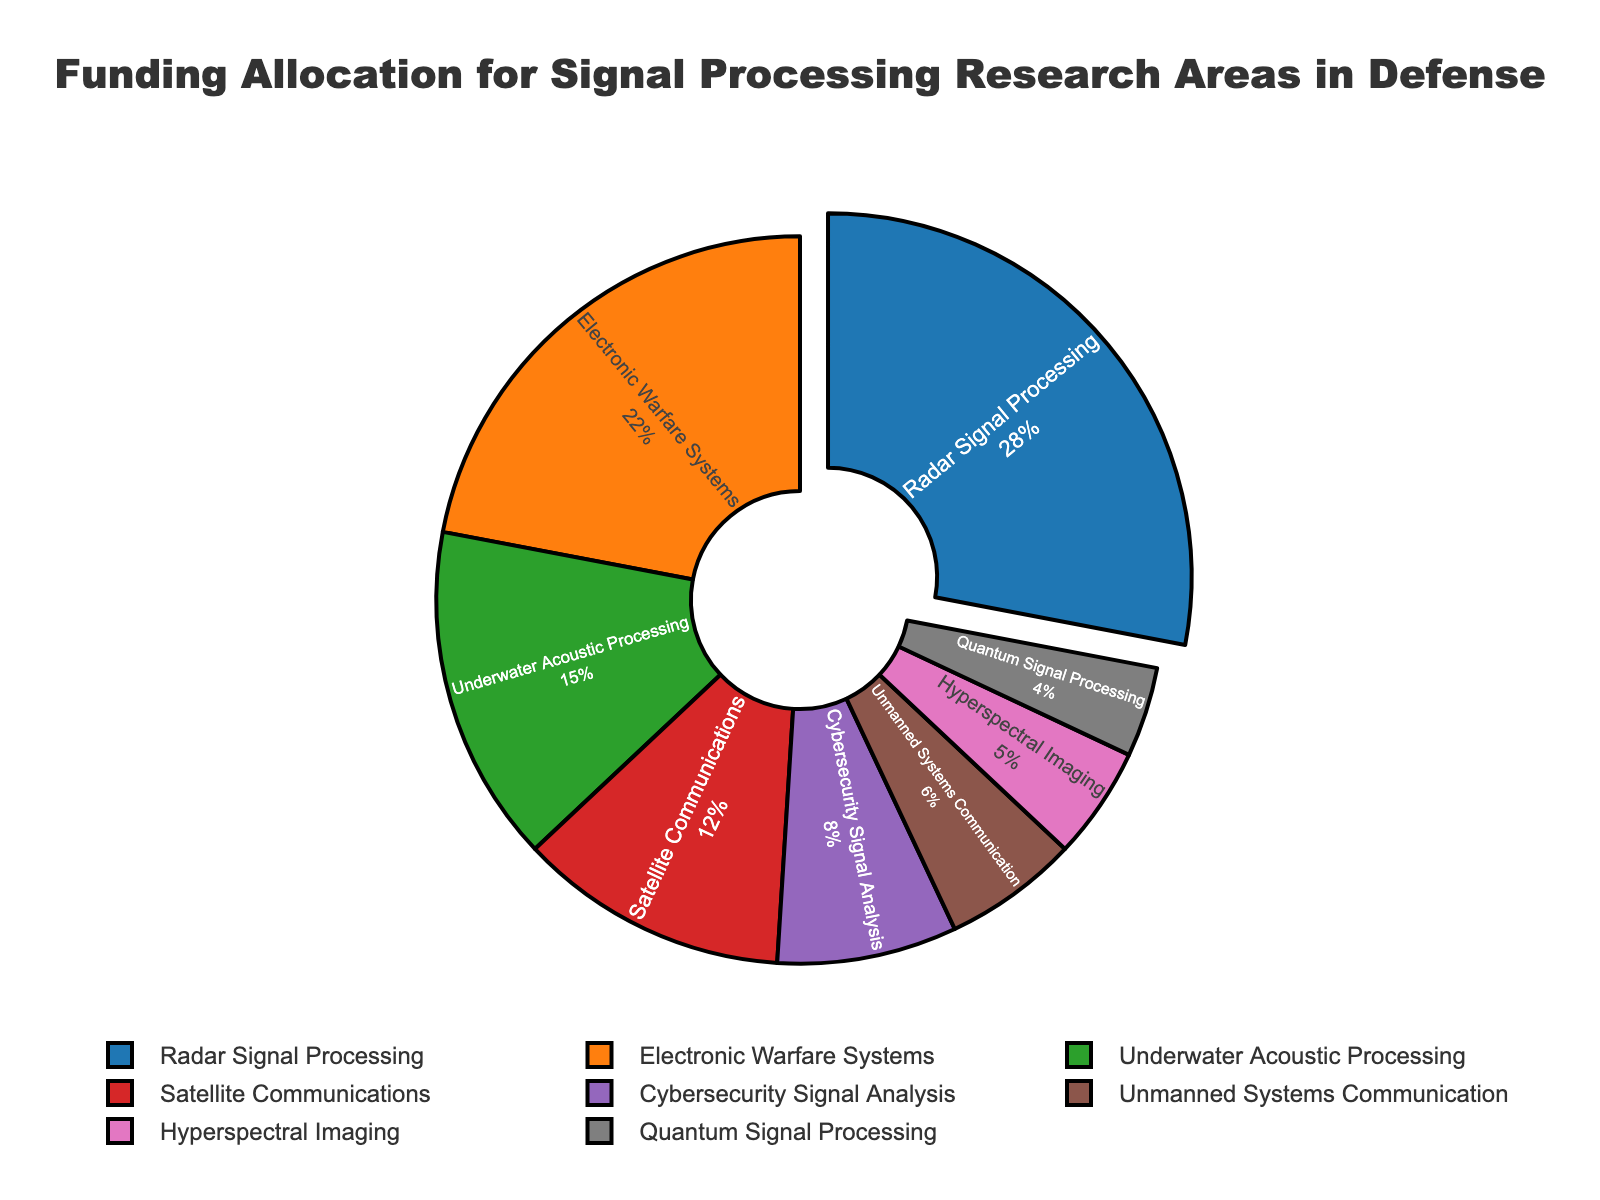Which research area receives the largest portion of funding allocation? The research area with the largest portion of funding allocation is indicated by the section pulled out of the pie chart and also labeled with the highest percentage.
Answer: Radar Signal Processing What is the combined funding allocation percentage for Underwater Acoustic Processing and Satellite Communications? Add the percentages for Underwater Acoustic Processing (15%) and Satellite Communications (12%). 15% + 12% = 27%
Answer: 27% How much more funding allocation is given to Electronic Warfare Systems than to Cybersecurity Signal Analysis? Subtract the funding allocation of Cybersecurity Signal Analysis (8%) from Electronic Warfare Systems (22%). 22% - 8% = 14%
Answer: 14% Which research area has the smallest funding allocation? The smallest section of the pie chart represents Quantum Signal Processing, and it is labeled with 4%.
Answer: Quantum Signal Processing Is the funding allocation for Hyperspectral Imaging greater than for Unmanned Systems Communication? Compare the percentages of Hyperspectral Imaging (5%) and Unmanned Systems Communication (6%). Hyperspectral Imaging has a lower percentage.
Answer: No What is the average funding allocation percentage for Electronic Warfare Systems, Cybersecurity Signal Analysis, and Quantum Signal Processing? Add the percentages of Electronic Warfare Systems (22%), Cybersecurity Signal Analysis (8%), and Quantum Signal Processing (4%), and then divide by 3. (22% + 8% + 4%) / 3 = 34% / 3 ≈ 11.33%
Answer: 11.33% What total percentage of the funding is allotted to the top three research areas? Add the percentages for Radar Signal Processing (28%), Electronic Warfare Systems (22%), and Underwater Acoustic Processing (15%). 28% + 22% + 15% = 65%
Answer: 65% Which color represents the second highest funded research area? The second highest funded research area is Electronic Warfare Systems, which is colored in orange.
Answer: Orange Does the combined funding allocation for Cybersecurity Signal Analysis and Unmanned Systems Communication exceed that of Radar Signal Processing? Add the percentages of Cybersecurity Signal Analysis (8%) and Unmanned Systems Communication (6%), and compare it with Radar Signal Processing (28%). 8% + 6% = 14%, which is less than 28%.
Answer: No Among the research areas with less than 10% funding allocation, which one has the highest allocation? Among the areas with less than 10% funding allocation (Cybersecurity Signal Analysis, Unmanned Systems Communication, Hyperspectral Imaging, Quantum Signal Processing), Cybersecurity Signal Analysis has the highest percentage (8%).
Answer: Cybersecurity Signal Analysis 